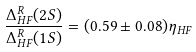<formula> <loc_0><loc_0><loc_500><loc_500>\frac { \Delta _ { H F } ^ { R } ( 2 S ) } { \Delta _ { H F } ^ { R } ( 1 S ) } = ( 0 . 5 9 \pm 0 . 0 8 ) \eta _ { H F }</formula> 